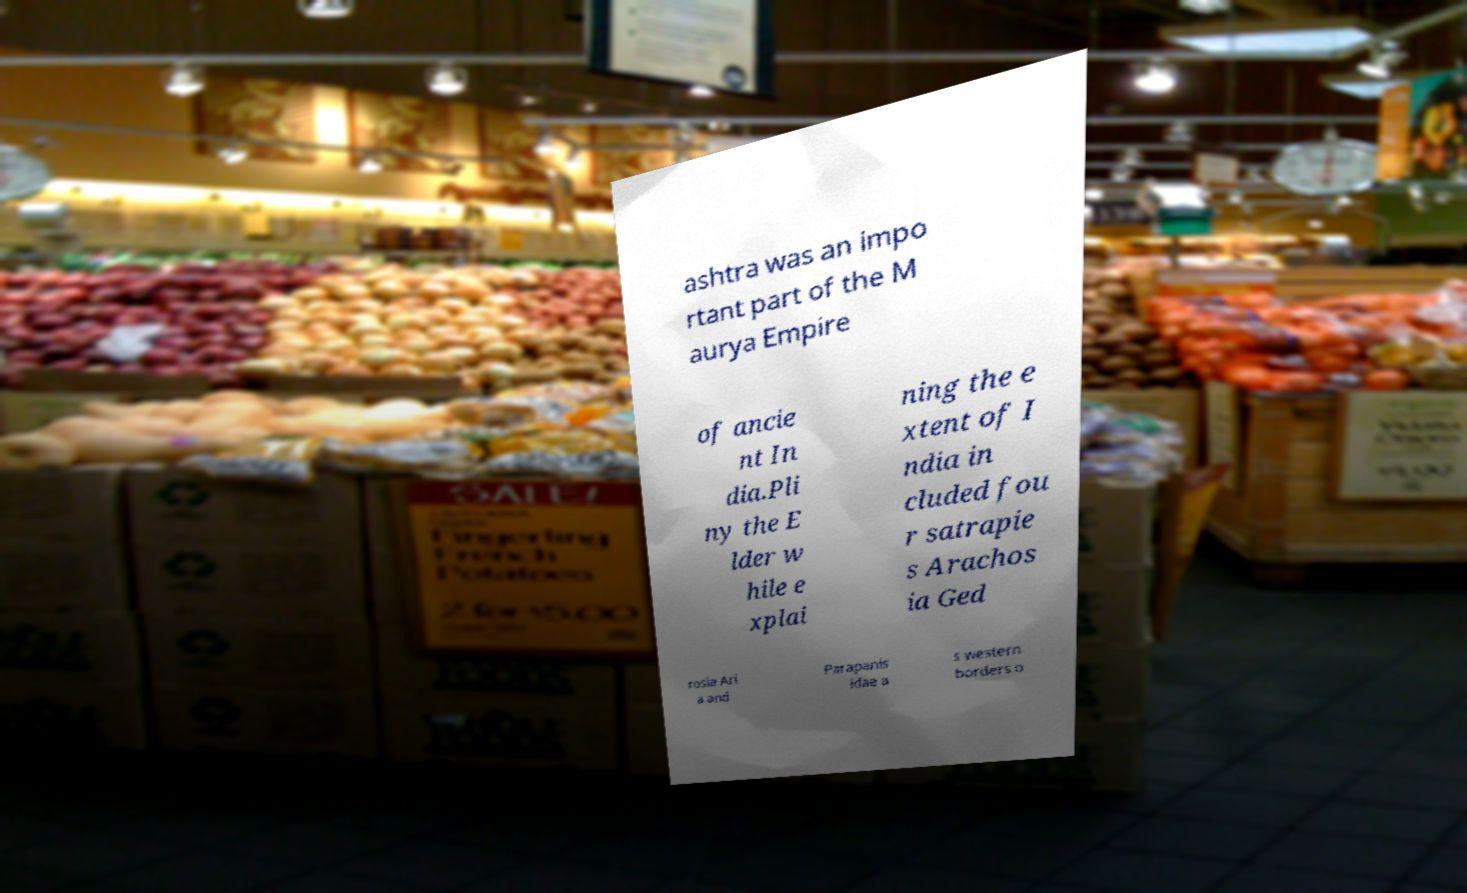Can you read and provide the text displayed in the image?This photo seems to have some interesting text. Can you extract and type it out for me? ashtra was an impo rtant part of the M aurya Empire of ancie nt In dia.Pli ny the E lder w hile e xplai ning the e xtent of I ndia in cluded fou r satrapie s Arachos ia Ged rosia Ari a and Parapanis idae a s western borders o 